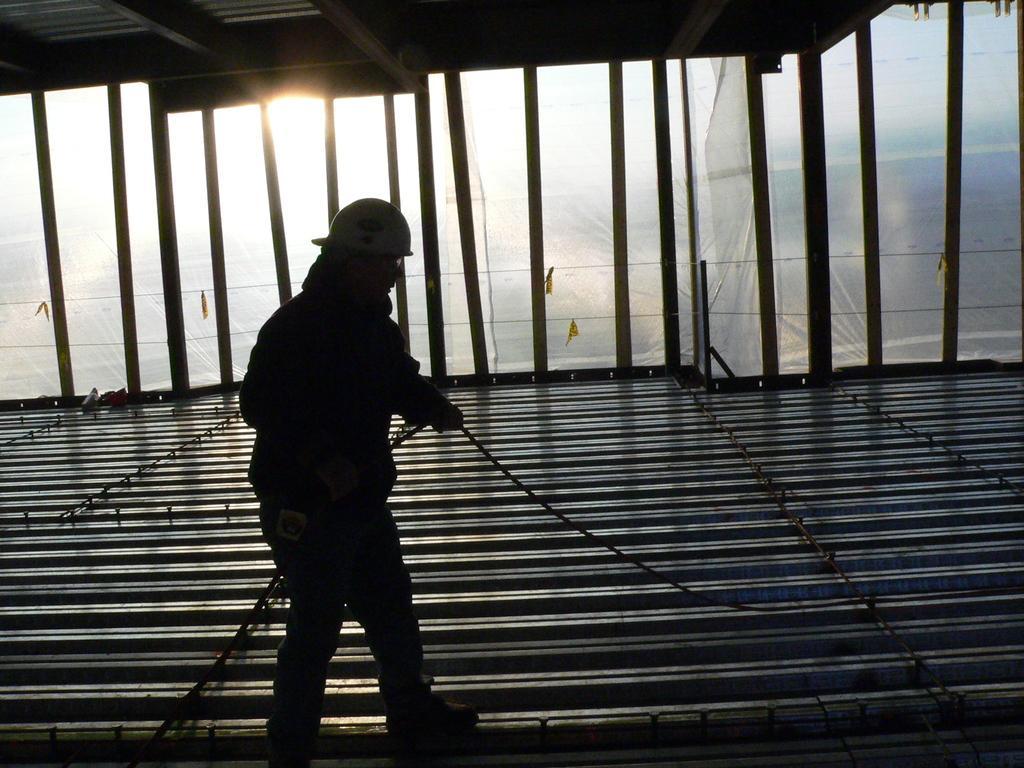In one or two sentences, can you explain what this image depicts? in the given picture i can see a person holding a rope and wearing a cap and also wearing a specs and also behind the person i can see a room which is build with glass and i can see a cover sheets and also i can see sun. 